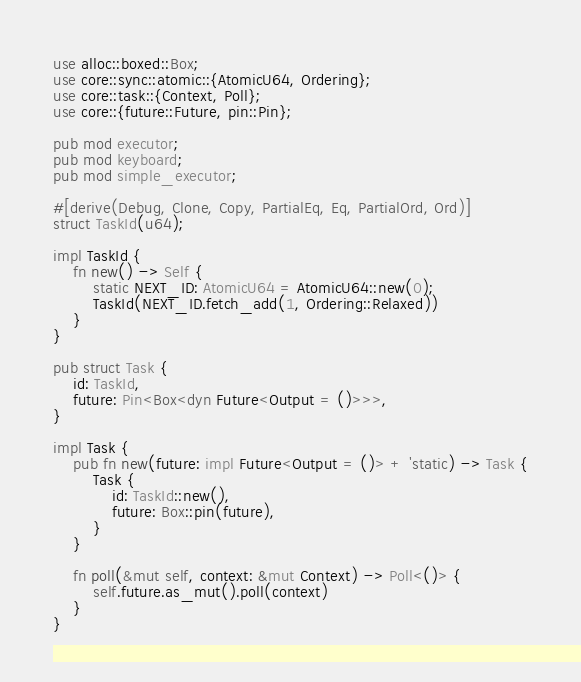Convert code to text. <code><loc_0><loc_0><loc_500><loc_500><_Rust_>use alloc::boxed::Box;
use core::sync::atomic::{AtomicU64, Ordering};
use core::task::{Context, Poll};
use core::{future::Future, pin::Pin};

pub mod executor;
pub mod keyboard;
pub mod simple_executor;

#[derive(Debug, Clone, Copy, PartialEq, Eq, PartialOrd, Ord)]
struct TaskId(u64);

impl TaskId {
    fn new() -> Self {
        static NEXT_ID: AtomicU64 = AtomicU64::new(0);
        TaskId(NEXT_ID.fetch_add(1, Ordering::Relaxed))
    }
}

pub struct Task {
    id: TaskId,
    future: Pin<Box<dyn Future<Output = ()>>>,
}

impl Task {
    pub fn new(future: impl Future<Output = ()> + 'static) -> Task {
        Task {
            id: TaskId::new(),
            future: Box::pin(future),
        }
    }

    fn poll(&mut self, context: &mut Context) -> Poll<()> {
        self.future.as_mut().poll(context)
    }
}
</code> 